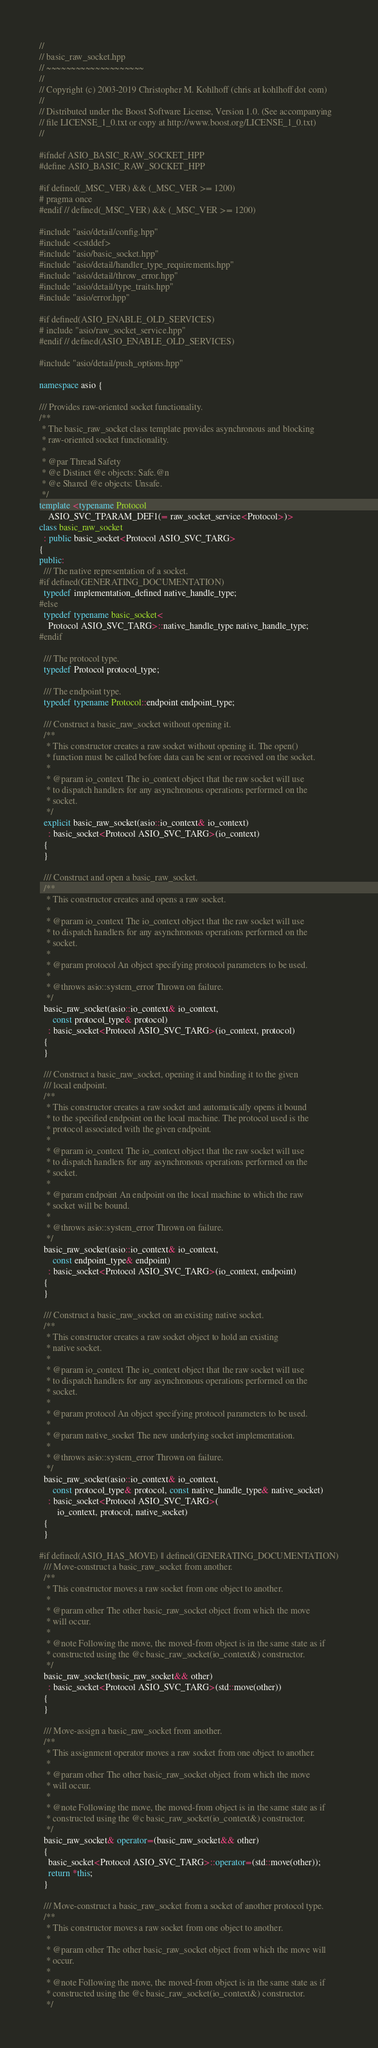Convert code to text. <code><loc_0><loc_0><loc_500><loc_500><_C++_>//
// basic_raw_socket.hpp
// ~~~~~~~~~~~~~~~~~~~~
//
// Copyright (c) 2003-2019 Christopher M. Kohlhoff (chris at kohlhoff dot com)
//
// Distributed under the Boost Software License, Version 1.0. (See accompanying
// file LICENSE_1_0.txt or copy at http://www.boost.org/LICENSE_1_0.txt)
//

#ifndef ASIO_BASIC_RAW_SOCKET_HPP
#define ASIO_BASIC_RAW_SOCKET_HPP

#if defined(_MSC_VER) && (_MSC_VER >= 1200)
# pragma once
#endif // defined(_MSC_VER) && (_MSC_VER >= 1200)

#include "asio/detail/config.hpp"
#include <cstddef>
#include "asio/basic_socket.hpp"
#include "asio/detail/handler_type_requirements.hpp"
#include "asio/detail/throw_error.hpp"
#include "asio/detail/type_traits.hpp"
#include "asio/error.hpp"

#if defined(ASIO_ENABLE_OLD_SERVICES)
# include "asio/raw_socket_service.hpp"
#endif // defined(ASIO_ENABLE_OLD_SERVICES)

#include "asio/detail/push_options.hpp"

namespace asio {

/// Provides raw-oriented socket functionality.
/**
 * The basic_raw_socket class template provides asynchronous and blocking
 * raw-oriented socket functionality.
 *
 * @par Thread Safety
 * @e Distinct @e objects: Safe.@n
 * @e Shared @e objects: Unsafe.
 */
template <typename Protocol
    ASIO_SVC_TPARAM_DEF1(= raw_socket_service<Protocol>)>
class basic_raw_socket
  : public basic_socket<Protocol ASIO_SVC_TARG>
{
public:
  /// The native representation of a socket.
#if defined(GENERATING_DOCUMENTATION)
  typedef implementation_defined native_handle_type;
#else
  typedef typename basic_socket<
    Protocol ASIO_SVC_TARG>::native_handle_type native_handle_type;
#endif

  /// The protocol type.
  typedef Protocol protocol_type;

  /// The endpoint type.
  typedef typename Protocol::endpoint endpoint_type;

  /// Construct a basic_raw_socket without opening it.
  /**
   * This constructor creates a raw socket without opening it. The open()
   * function must be called before data can be sent or received on the socket.
   *
   * @param io_context The io_context object that the raw socket will use
   * to dispatch handlers for any asynchronous operations performed on the
   * socket.
   */
  explicit basic_raw_socket(asio::io_context& io_context)
    : basic_socket<Protocol ASIO_SVC_TARG>(io_context)
  {
  }

  /// Construct and open a basic_raw_socket.
  /**
   * This constructor creates and opens a raw socket.
   *
   * @param io_context The io_context object that the raw socket will use
   * to dispatch handlers for any asynchronous operations performed on the
   * socket.
   *
   * @param protocol An object specifying protocol parameters to be used.
   *
   * @throws asio::system_error Thrown on failure.
   */
  basic_raw_socket(asio::io_context& io_context,
      const protocol_type& protocol)
    : basic_socket<Protocol ASIO_SVC_TARG>(io_context, protocol)
  {
  }

  /// Construct a basic_raw_socket, opening it and binding it to the given
  /// local endpoint.
  /**
   * This constructor creates a raw socket and automatically opens it bound
   * to the specified endpoint on the local machine. The protocol used is the
   * protocol associated with the given endpoint.
   *
   * @param io_context The io_context object that the raw socket will use
   * to dispatch handlers for any asynchronous operations performed on the
   * socket.
   *
   * @param endpoint An endpoint on the local machine to which the raw
   * socket will be bound.
   *
   * @throws asio::system_error Thrown on failure.
   */
  basic_raw_socket(asio::io_context& io_context,
      const endpoint_type& endpoint)
    : basic_socket<Protocol ASIO_SVC_TARG>(io_context, endpoint)
  {
  }

  /// Construct a basic_raw_socket on an existing native socket.
  /**
   * This constructor creates a raw socket object to hold an existing
   * native socket.
   *
   * @param io_context The io_context object that the raw socket will use
   * to dispatch handlers for any asynchronous operations performed on the
   * socket.
   *
   * @param protocol An object specifying protocol parameters to be used.
   *
   * @param native_socket The new underlying socket implementation.
   *
   * @throws asio::system_error Thrown on failure.
   */
  basic_raw_socket(asio::io_context& io_context,
      const protocol_type& protocol, const native_handle_type& native_socket)
    : basic_socket<Protocol ASIO_SVC_TARG>(
        io_context, protocol, native_socket)
  {
  }

#if defined(ASIO_HAS_MOVE) || defined(GENERATING_DOCUMENTATION)
  /// Move-construct a basic_raw_socket from another.
  /**
   * This constructor moves a raw socket from one object to another.
   *
   * @param other The other basic_raw_socket object from which the move
   * will occur.
   *
   * @note Following the move, the moved-from object is in the same state as if
   * constructed using the @c basic_raw_socket(io_context&) constructor.
   */
  basic_raw_socket(basic_raw_socket&& other)
    : basic_socket<Protocol ASIO_SVC_TARG>(std::move(other))
  {
  }

  /// Move-assign a basic_raw_socket from another.
  /**
   * This assignment operator moves a raw socket from one object to another.
   *
   * @param other The other basic_raw_socket object from which the move
   * will occur.
   *
   * @note Following the move, the moved-from object is in the same state as if
   * constructed using the @c basic_raw_socket(io_context&) constructor.
   */
  basic_raw_socket& operator=(basic_raw_socket&& other)
  {
    basic_socket<Protocol ASIO_SVC_TARG>::operator=(std::move(other));
    return *this;
  }

  /// Move-construct a basic_raw_socket from a socket of another protocol type.
  /**
   * This constructor moves a raw socket from one object to another.
   *
   * @param other The other basic_raw_socket object from which the move will
   * occur.
   *
   * @note Following the move, the moved-from object is in the same state as if
   * constructed using the @c basic_raw_socket(io_context&) constructor.
   */</code> 